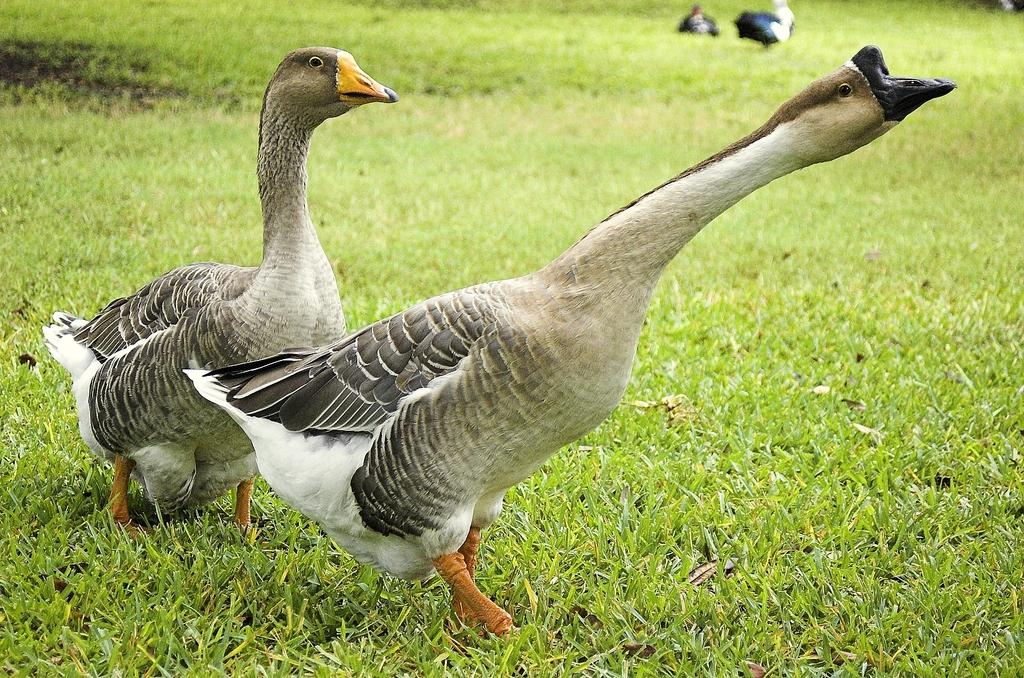What animals are in the center of the image? There are two ducks in the center of the image. What type of vegetation is at the bottom of the image? There is grass at the bottom of the image. How many fingers can be seen on the ducks in the image? Ducks do not have fingers, so none can be seen on them in the image. 